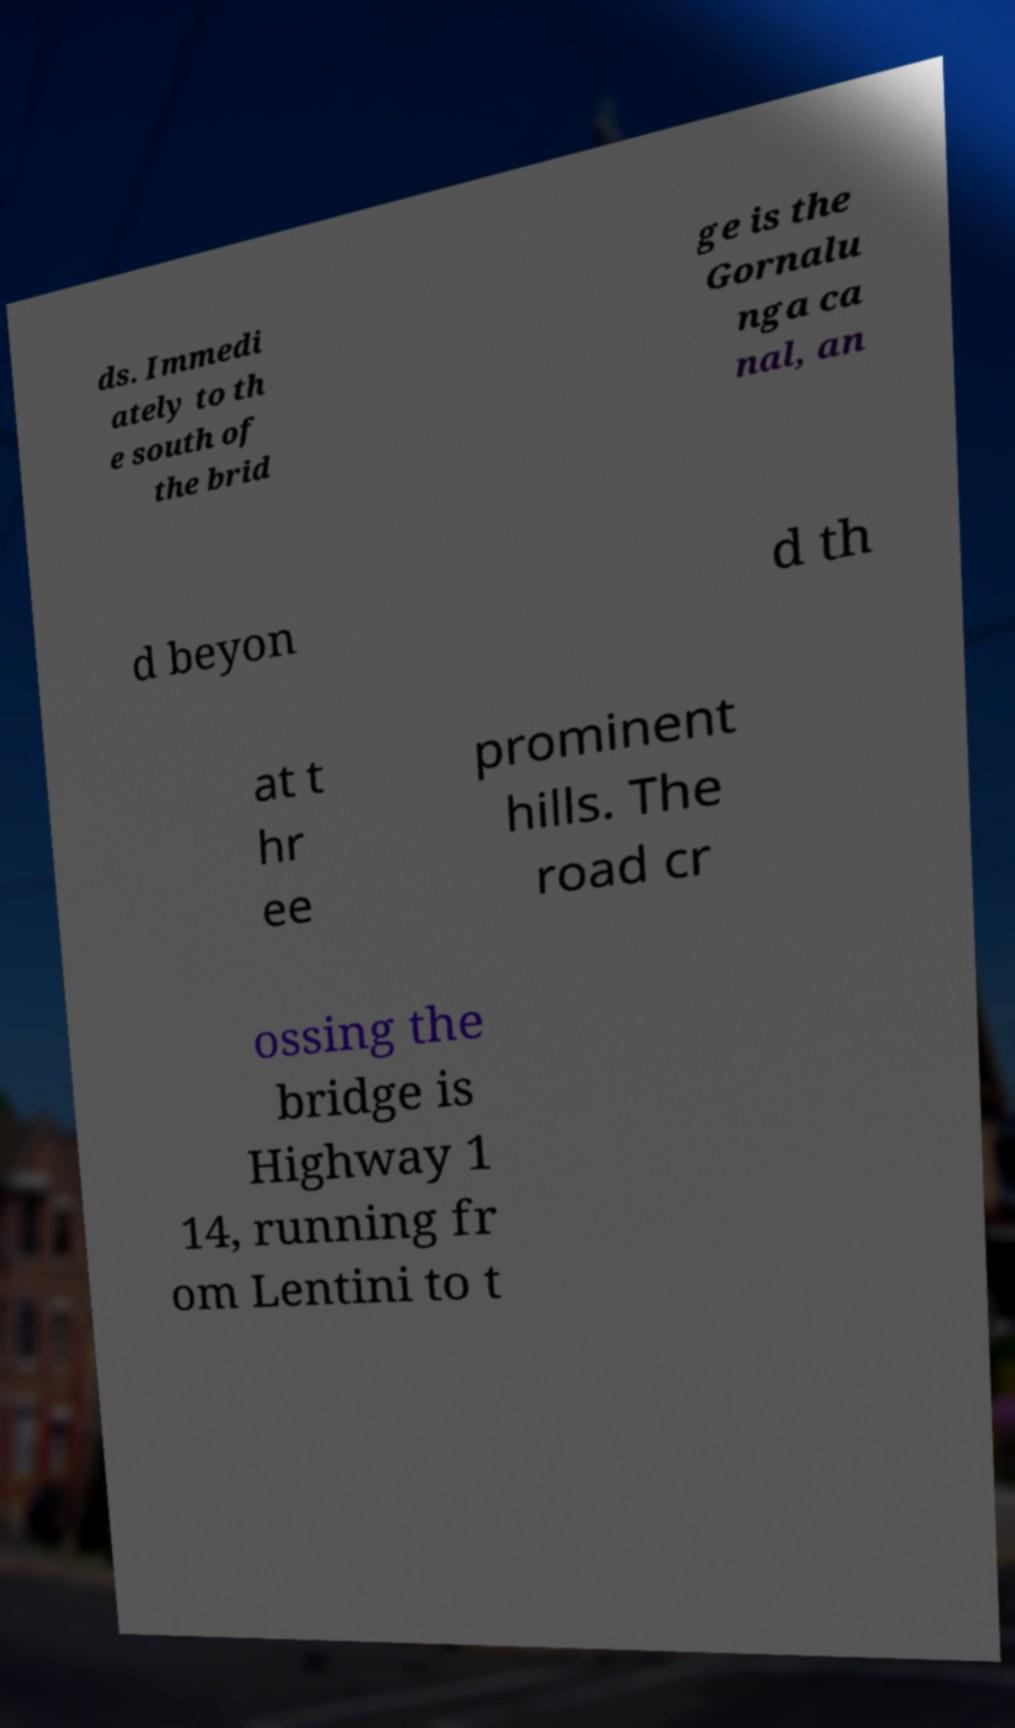Could you assist in decoding the text presented in this image and type it out clearly? ds. Immedi ately to th e south of the brid ge is the Gornalu nga ca nal, an d beyon d th at t hr ee prominent hills. The road cr ossing the bridge is Highway 1 14, running fr om Lentini to t 